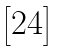<formula> <loc_0><loc_0><loc_500><loc_500>\begin{bmatrix} 2 4 \end{bmatrix}</formula> 